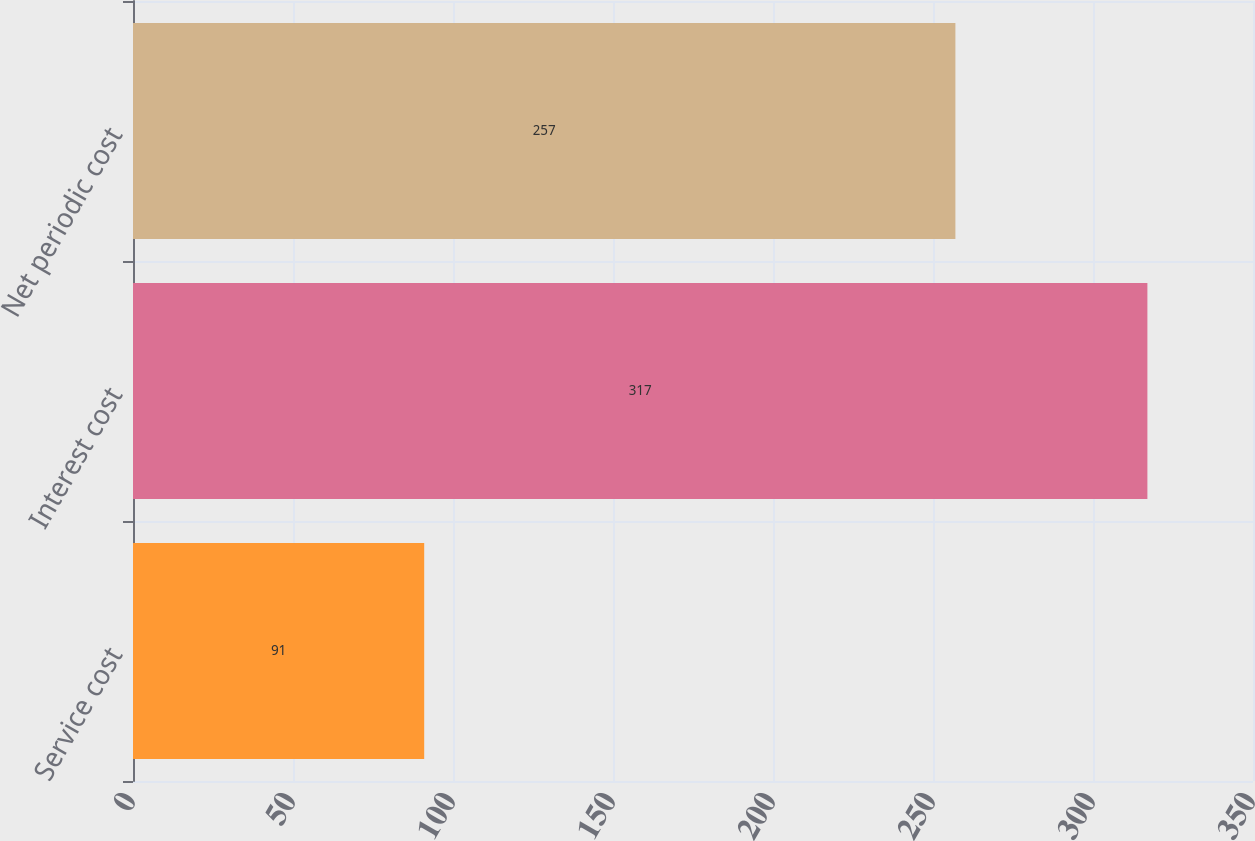Convert chart. <chart><loc_0><loc_0><loc_500><loc_500><bar_chart><fcel>Service cost<fcel>Interest cost<fcel>Net periodic cost<nl><fcel>91<fcel>317<fcel>257<nl></chart> 